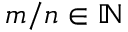Convert formula to latex. <formula><loc_0><loc_0><loc_500><loc_500>m / n \in \mathbb { N }</formula> 